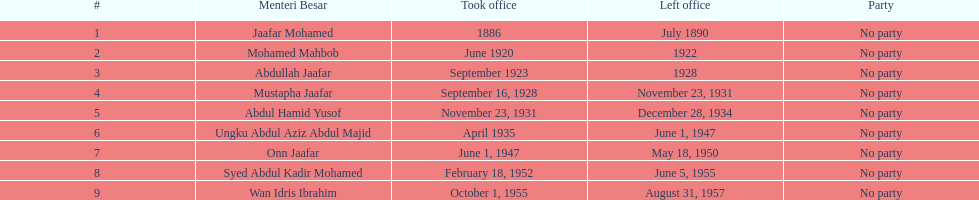Other than abullah jaafar, name someone with the same last name. Mustapha Jaafar. 